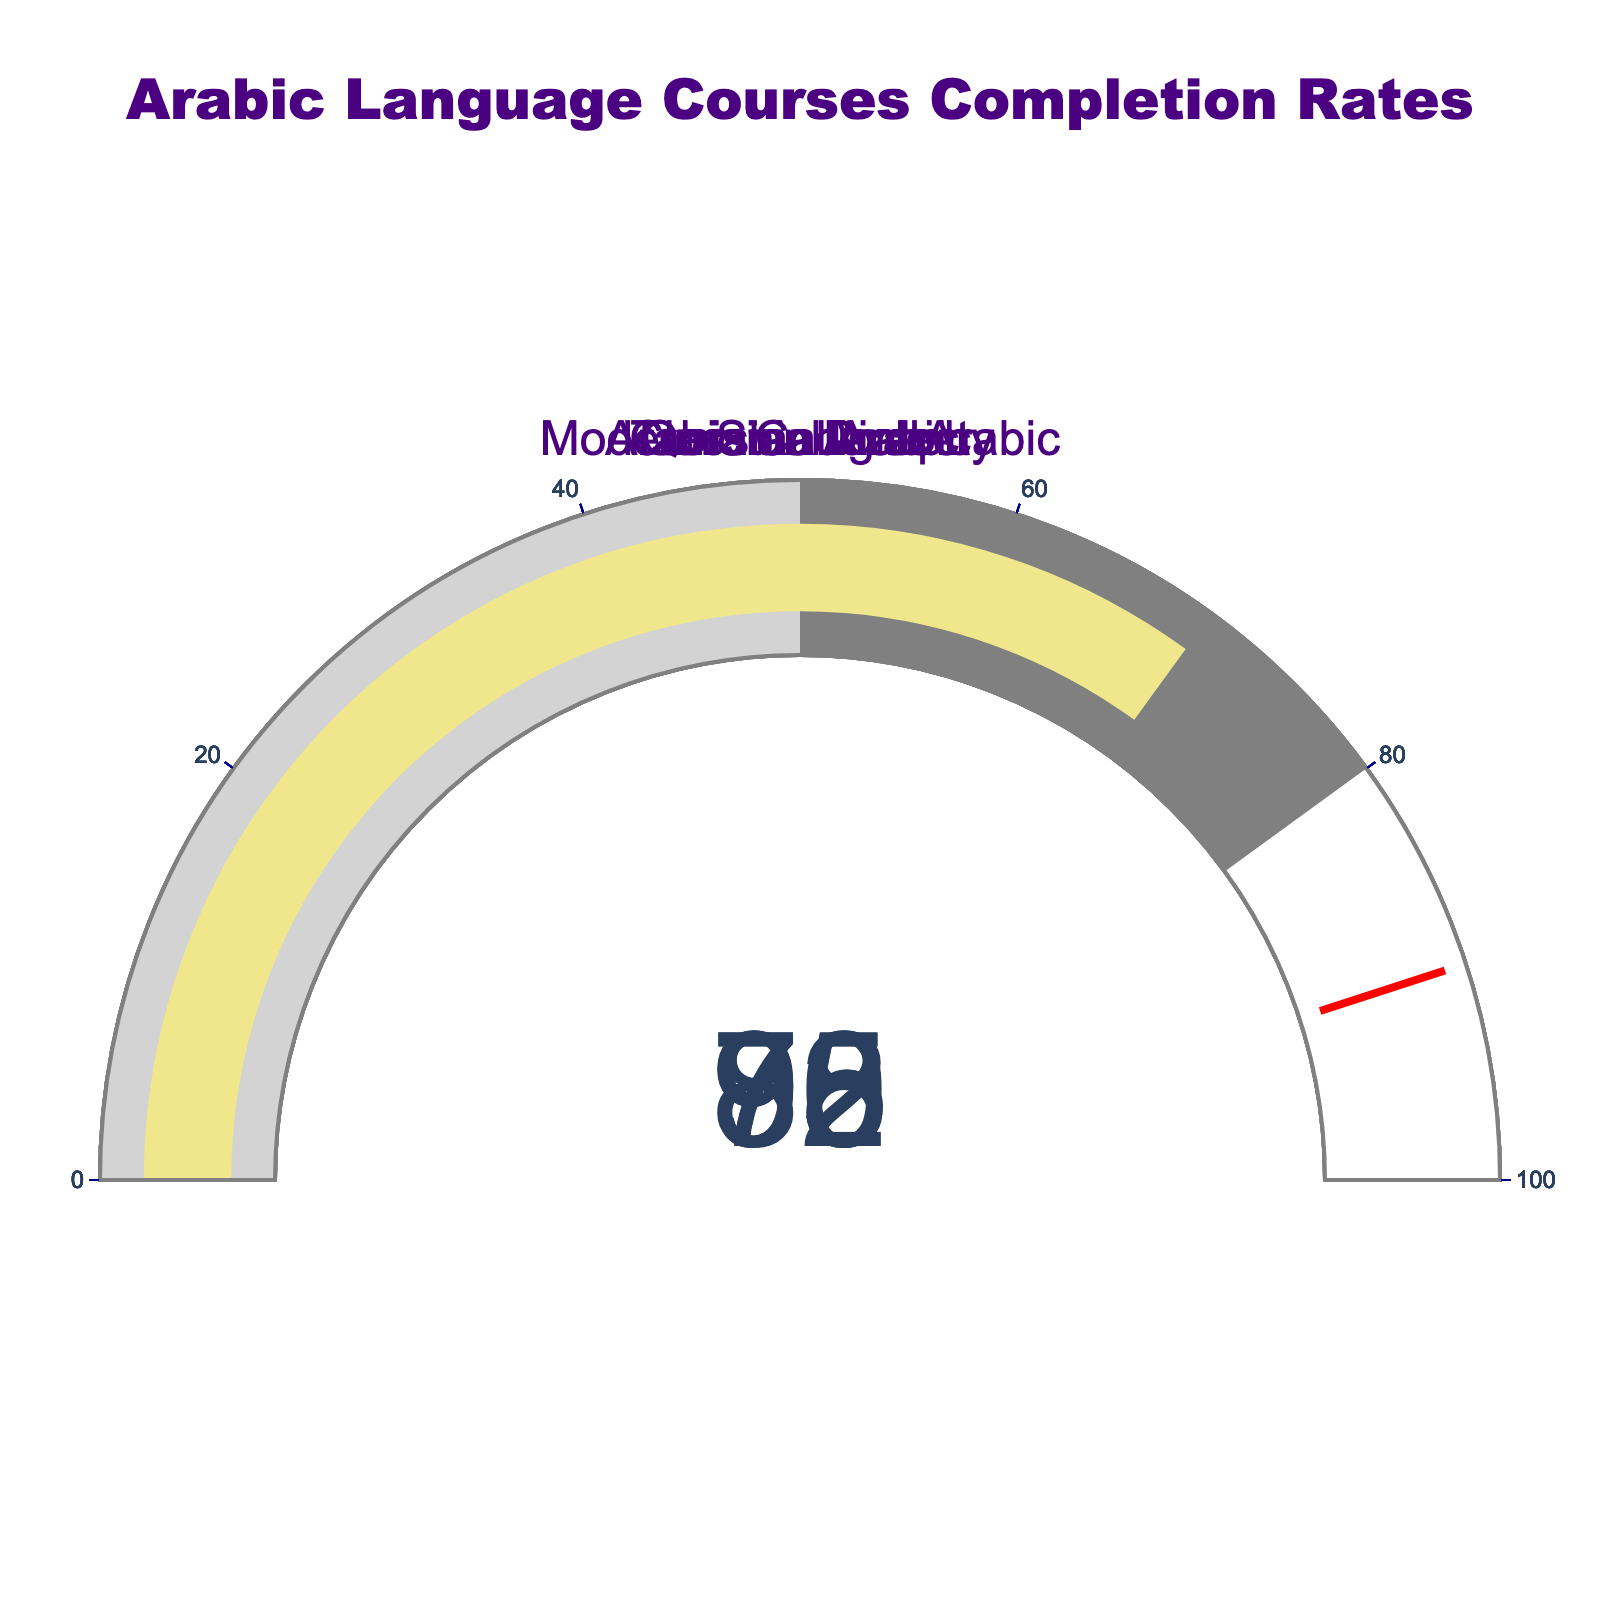What's the completion rate for Quranic Arabic? The gauge for Quranic Arabic shows a completion rate. This is a basic element in the figure.
Answer: 92 How many courses have a completion rate above 80? Look at each gauge and count how many show a value above 80. Classical Arabic (85), Quranic Arabic (92), and Tunisian Dialect (95) are above 80.
Answer: 3 Which course has the lowest completion rate? Compare the values on each gauge to determine the smallest one. Arabic Calligraphy has the lowest rate.
Answer: Arabic Calligraphy What's the difference in completion rate between Modern Standard Arabic and Tunisian Dialect? Find the completion rates for both courses and subtract one from the other (95 - 78).
Answer: 17 If you sum the completion rates of all courses, what would be the total? Add up the completion rates: 85 (Classical Arabic) + 92 (Quranic Arabic) + 78 (Modern Standard Arabic) + 95 (Tunisian Dialect) + 70 (Arabic Calligraphy) = 420.
Answer: 420 Which course has the highest completion rate? Look at each gauge to determine the highest value, which is for Tunisian Dialect at 95.
Answer: Tunisian Dialect Are there any courses with a completion rate between 70 and 80? Check each gauge to see if any fall within the range of 70 to 80. Only Modern Standard Arabic (78) falls within this range.
Answer: Yes What is the average completion rate for all courses? Add all the completion rates and divide by the number of courses: (85 + 92 + 78 + 95 + 70) / 5 = 84.
Answer: 84 Which two courses have a combined completion rate of 177? Look at different combinations of the completion rates to find the pair that sums to 177. Classical Arabic (85) and Tunisian Dialect (95) sum to 180, which is closest, but not exact. The exact combination isn't readily visible in the data given.
Answer: No exact match 